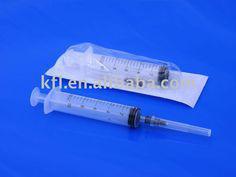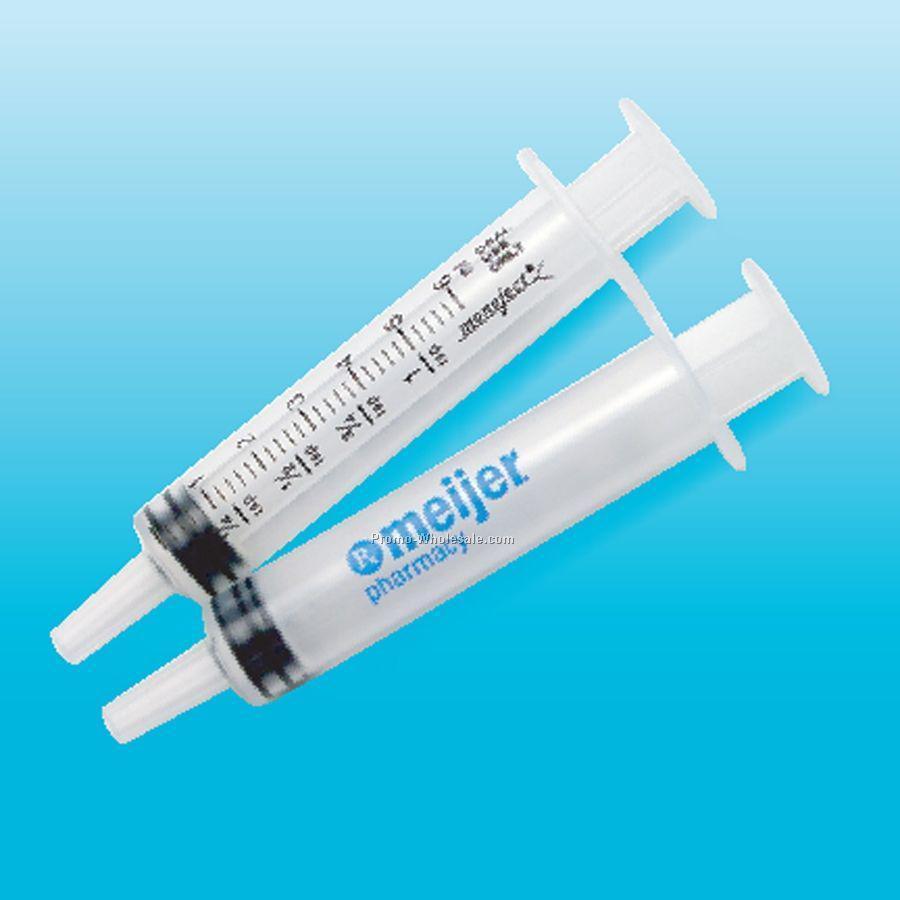The first image is the image on the left, the second image is the image on the right. Analyze the images presented: Is the assertion "One image shows two unwrapped syringe items, arranged side-by-side at an angle." valid? Answer yes or no. Yes. The first image is the image on the left, the second image is the image on the right. Analyze the images presented: Is the assertion "One of the images contains more than five syringes." valid? Answer yes or no. No. 